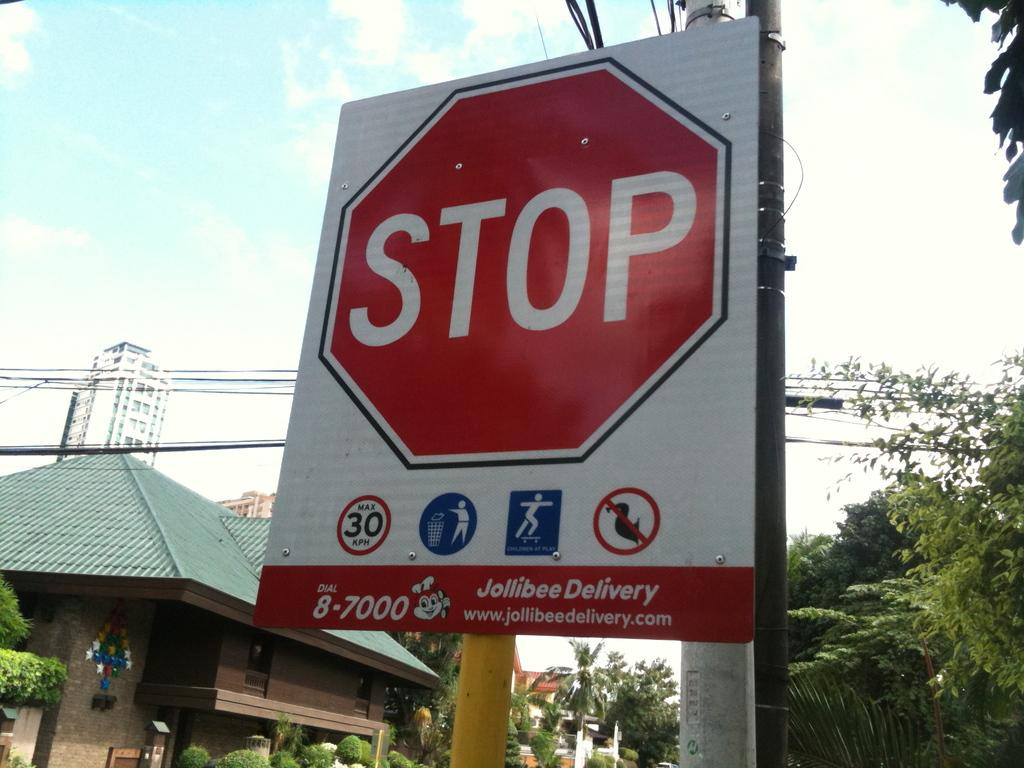<image>
Create a compact narrative representing the image presented. Stop Sign hosted by Jollibee Delivery, Max Speed is 30 KPH. 